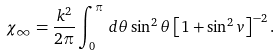Convert formula to latex. <formula><loc_0><loc_0><loc_500><loc_500>\chi _ { \infty } = \frac { k ^ { 2 } } { 2 \pi } \int _ { 0 } ^ { \pi } \, d \theta \sin ^ { 2 } \theta \left [ 1 + \sin ^ { 2 } v \right ] ^ { - 2 } .</formula> 